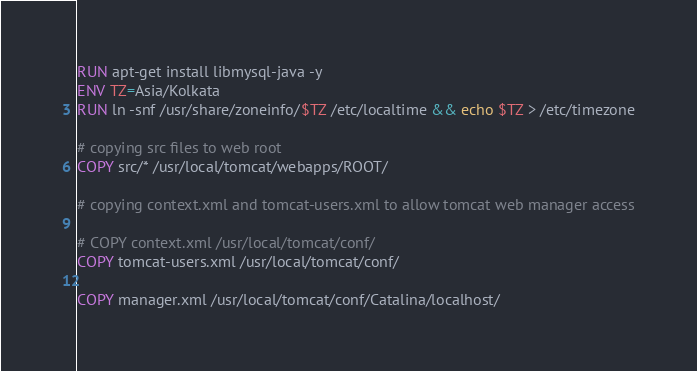Convert code to text. <code><loc_0><loc_0><loc_500><loc_500><_Dockerfile_>RUN apt-get install libmysql-java -y
ENV TZ=Asia/Kolkata
RUN ln -snf /usr/share/zoneinfo/$TZ /etc/localtime && echo $TZ > /etc/timezone

# copying src files to web root
COPY src/* /usr/local/tomcat/webapps/ROOT/

# copying context.xml and tomcat-users.xml to allow tomcat web manager access

# COPY context.xml /usr/local/tomcat/conf/
COPY tomcat-users.xml /usr/local/tomcat/conf/

COPY manager.xml /usr/local/tomcat/conf/Catalina/localhost/</code> 